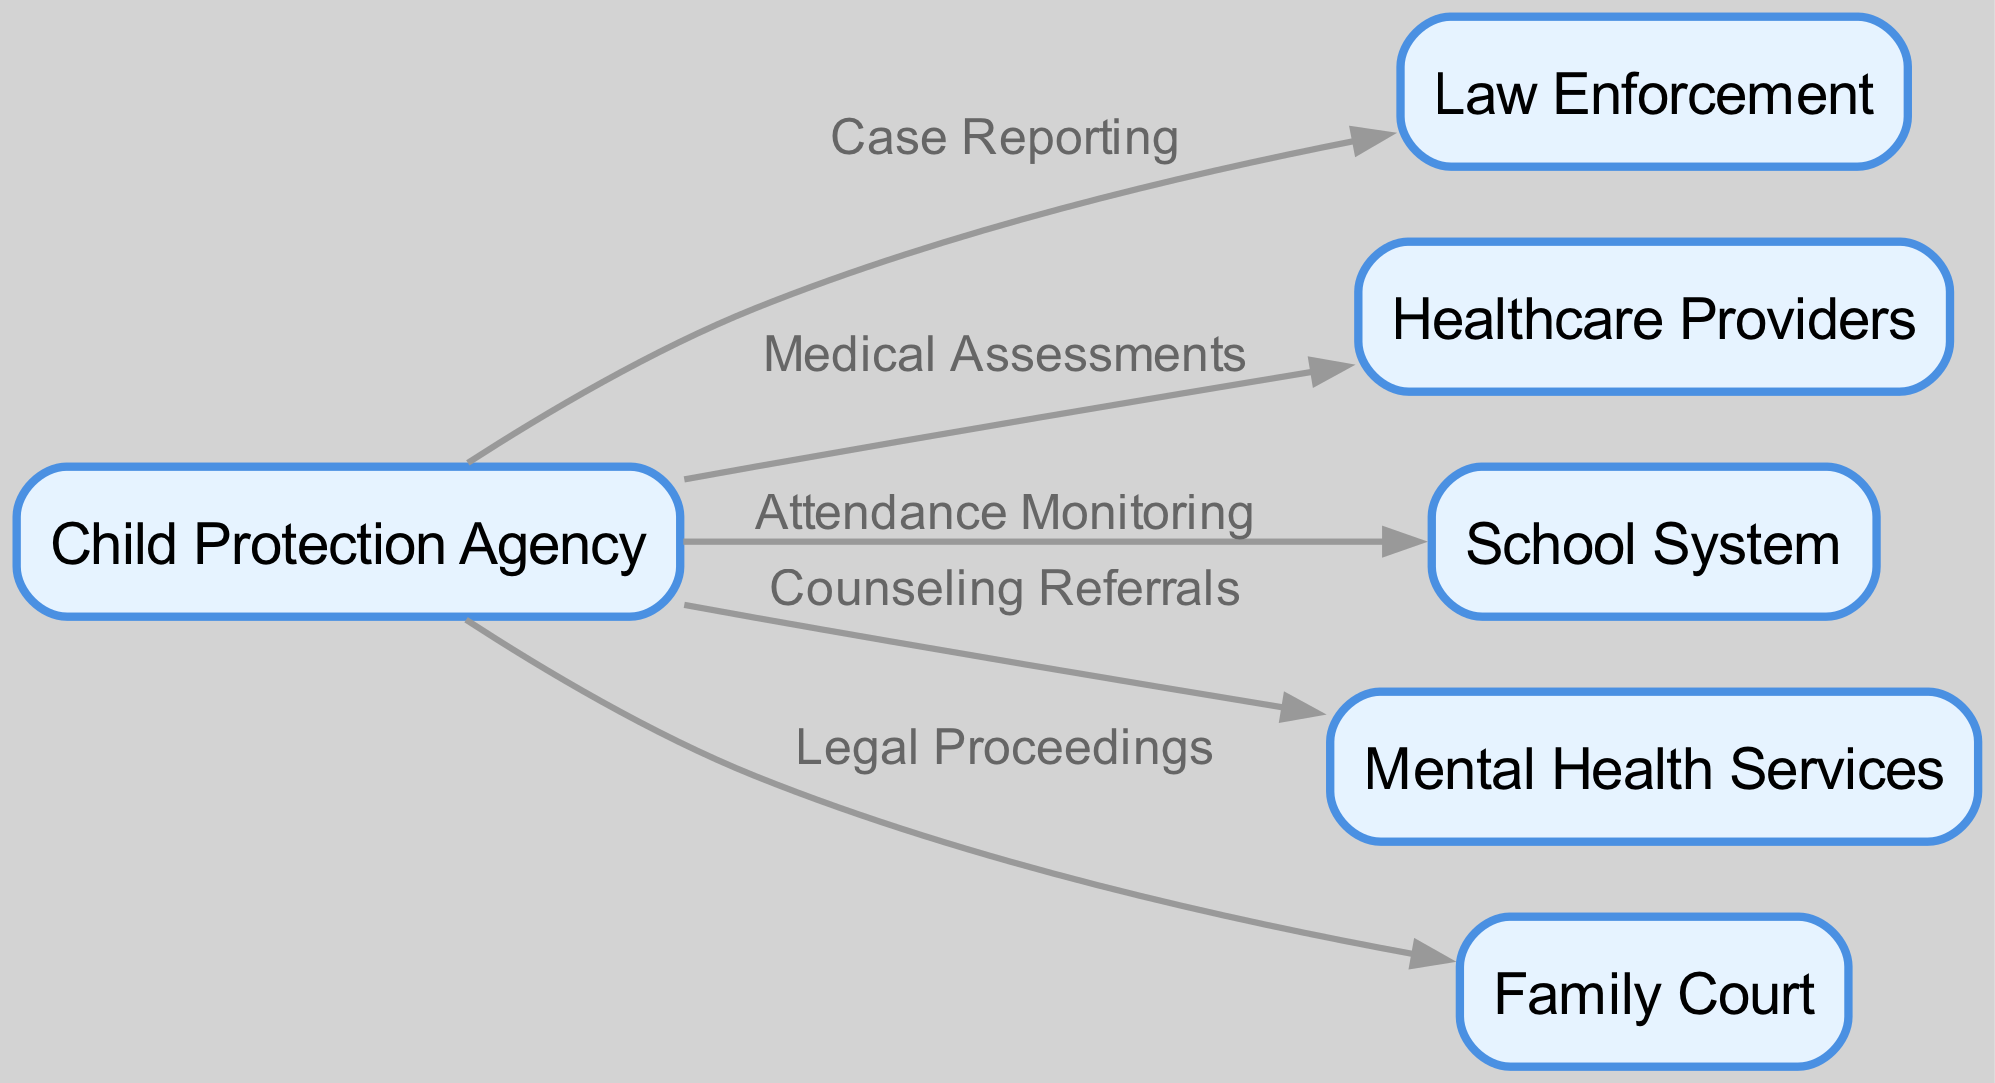What are the names of the agencies involved? The diagram lists six agencies: Child Protection Agency, Law Enforcement, Healthcare Providers, School System, Mental Health Services, and Family Court. Each agency represents a node in the diagram.
Answer: Child Protection Agency, Law Enforcement, Healthcare Providers, School System, Mental Health Services, Family Court How many nodes are in the diagram? By counting the distinct agencies represented in the diagram, we find a total of six nodes. The nodes correspond to the different organizations involved in the interagency collaboration model.
Answer: 6 What relationship exists between the Child Protection Agency and Law Enforcement? The diagram indicates that there is a directed edge labeled "Case Reporting" from the Child Protection Agency to Law Enforcement, suggesting that information is reported from one agency to the other.
Answer: Case Reporting What type of services are referred to by the edge from Child Protection Agency to Mental Health Services? The edge identifies the relationship as "Counseling Referrals," meaning that the Child Protection Agency refers cases in need of mental health support to the Mental Health Services agency.
Answer: Counseling Referrals Which agency is responsible for monitoring attendance? According to the connections in the diagram, attendance monitoring is linked directly to the School System through an edge labeled "Attendance Monitoring," indicating that the School System is responsible for this task.
Answer: School System What are the two types of assessments/monitorings indicated in the diagram? Exploring the edges, we see "Medical Assessments" linked to Healthcare Providers and "Attendance Monitoring" linked to the School System. These connections show two forms of assessment related to child welfare services represented in the diagram.
Answer: Medical Assessments, Attendance Monitoring How many edges connect the Child Protection Agency to other agencies? The diagram shows five edges emanating from the Child Protection Agency, each representing a form of collaboration with other agencies involved in child welfare.
Answer: 5 What is the legal process linked to the Child Protection Agency as seen in the diagram? The edge leading to Family Court indicates "Legal Proceedings," suggesting that the Child Protection Agency has a direct connection involving legal actions or procedures related to child welfare.
Answer: Legal Proceedings What kind of assessments are the Healthcare Providers involved in? The diagram shows a directed relationship indicated as "Medical Assessments" between the Child Protection Agency and Healthcare Providers, describing their collaboration in assessing the health of children involved in welfare cases.
Answer: Medical Assessments 